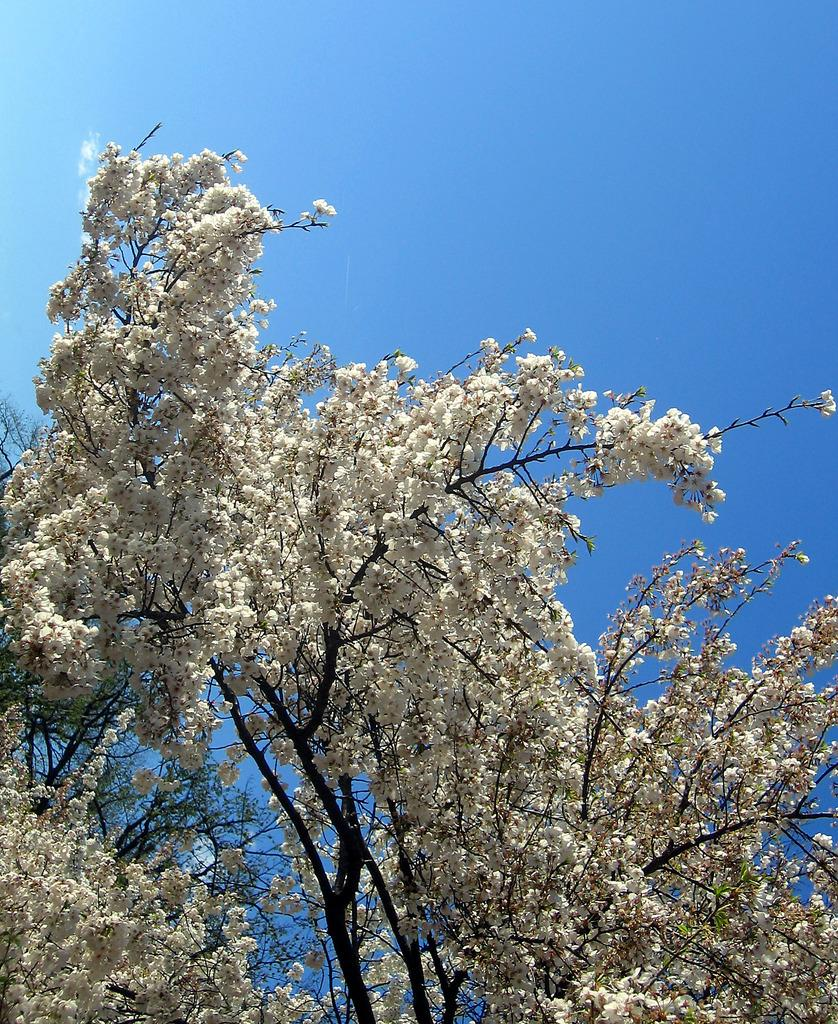What type of plant is the main subject of the image? There is a flower tree in the image. What is the color of the flower tree? The flower tree is white in color. Where is the flower tree located in the image? The flower tree is in the middle of the image. What can be seen in the background of the image? The sky is visible in the image. What is the condition of the sky in the image? The sky is clear and blue. What type of canvas is being used by the spy in the image? There is no canvas or spy present in the image; it features a flower tree and a clear blue sky. 